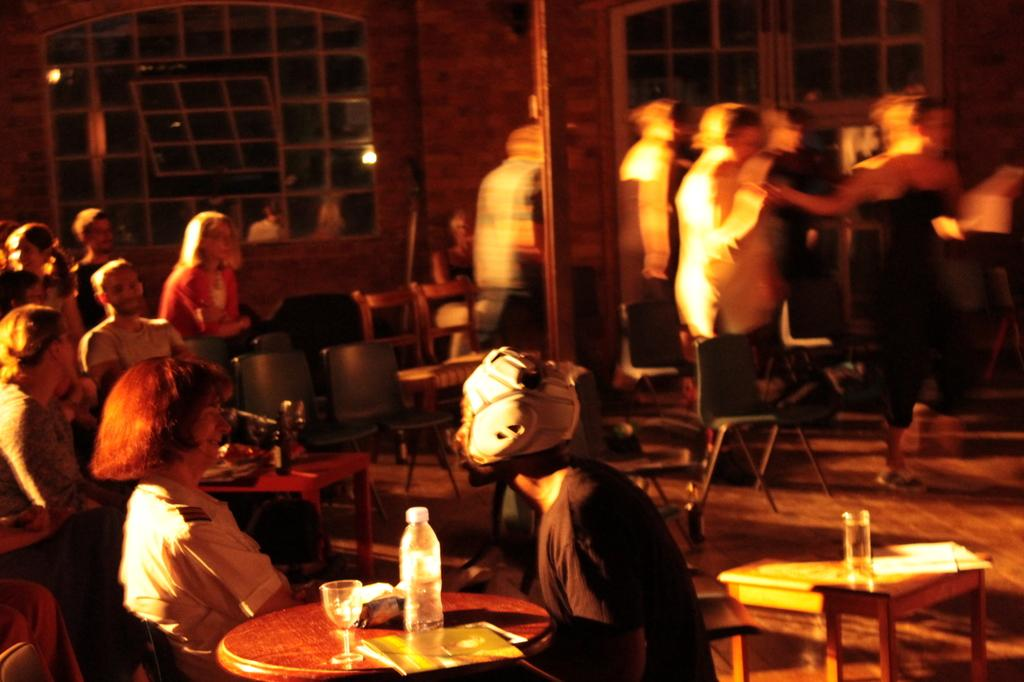What are the people in the image doing? The people in the image are sitting on chairs. What can be seen on the table in the image? There are wine glasses and a water bottle on the table. How many babies are crawling under the table in the image? There are no babies present in the image, and therefore no crawling babies can be observed. 